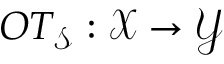<formula> <loc_0><loc_0><loc_500><loc_500>O T _ { \mathcal { S } } \colon \mathcal { X } \rightarrow \mathcal { Y }</formula> 